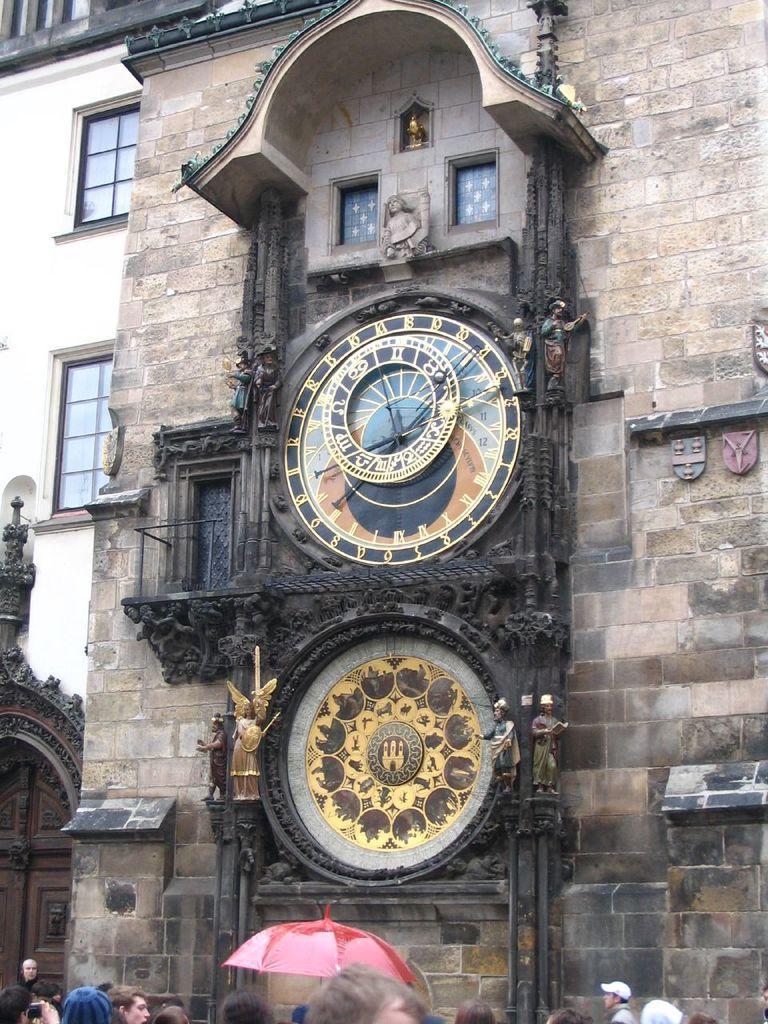Could you give a brief overview of what you see in this image? This is the picture of a building. In this image there is a clock and there are sculptures on the building. At the back there is an another building. At the bottom there are group of people and there is a door. 